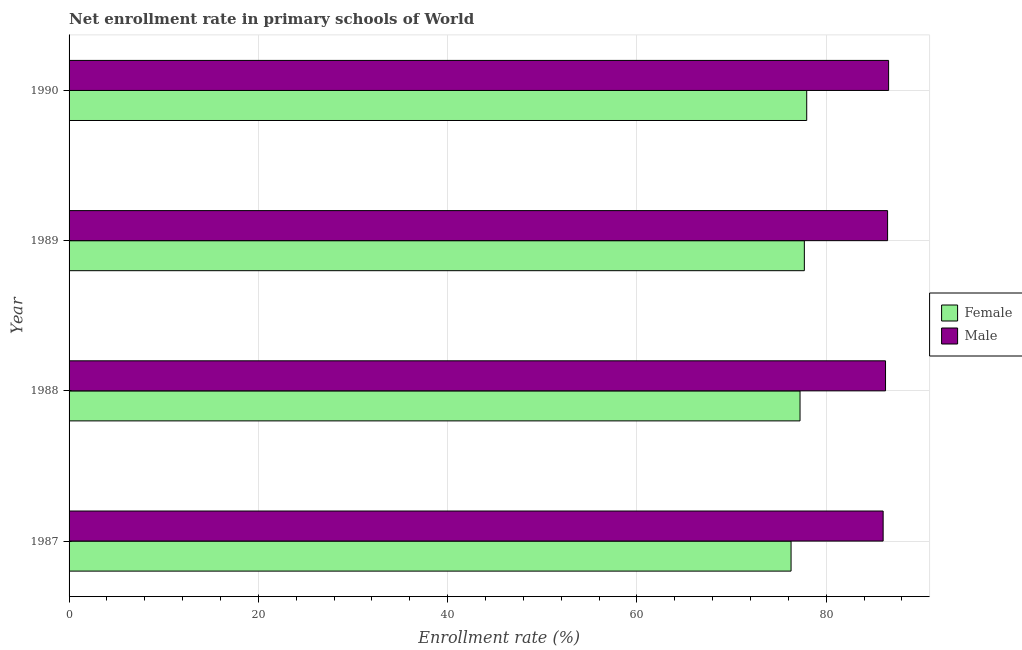How many groups of bars are there?
Make the answer very short. 4. Are the number of bars on each tick of the Y-axis equal?
Keep it short and to the point. Yes. How many bars are there on the 4th tick from the bottom?
Make the answer very short. 2. What is the label of the 2nd group of bars from the top?
Offer a very short reply. 1989. In how many cases, is the number of bars for a given year not equal to the number of legend labels?
Your answer should be compact. 0. What is the enrollment rate of male students in 1989?
Give a very brief answer. 86.49. Across all years, what is the maximum enrollment rate of male students?
Give a very brief answer. 86.6. Across all years, what is the minimum enrollment rate of female students?
Provide a succinct answer. 76.29. In which year was the enrollment rate of male students maximum?
Offer a terse response. 1990. In which year was the enrollment rate of female students minimum?
Your answer should be very brief. 1987. What is the total enrollment rate of male students in the graph?
Offer a terse response. 345.4. What is the difference between the enrollment rate of female students in 1988 and that in 1990?
Your answer should be compact. -0.71. What is the difference between the enrollment rate of male students in 1990 and the enrollment rate of female students in 1987?
Offer a terse response. 10.31. What is the average enrollment rate of male students per year?
Offer a very short reply. 86.35. In the year 1987, what is the difference between the enrollment rate of male students and enrollment rate of female students?
Ensure brevity in your answer.  9.73. In how many years, is the enrollment rate of male students greater than 64 %?
Make the answer very short. 4. What is the ratio of the enrollment rate of female students in 1988 to that in 1989?
Your answer should be very brief. 0.99. Is the difference between the enrollment rate of female students in 1989 and 1990 greater than the difference between the enrollment rate of male students in 1989 and 1990?
Your answer should be very brief. No. What is the difference between the highest and the second highest enrollment rate of female students?
Offer a very short reply. 0.25. What is the difference between the highest and the lowest enrollment rate of male students?
Ensure brevity in your answer.  0.58. What does the 2nd bar from the bottom in 1989 represents?
Keep it short and to the point. Male. Are all the bars in the graph horizontal?
Provide a succinct answer. Yes. What is the difference between two consecutive major ticks on the X-axis?
Offer a terse response. 20. Does the graph contain any zero values?
Your answer should be compact. No. Does the graph contain grids?
Provide a short and direct response. Yes. How many legend labels are there?
Offer a very short reply. 2. How are the legend labels stacked?
Provide a succinct answer. Vertical. What is the title of the graph?
Your response must be concise. Net enrollment rate in primary schools of World. What is the label or title of the X-axis?
Give a very brief answer. Enrollment rate (%). What is the label or title of the Y-axis?
Offer a terse response. Year. What is the Enrollment rate (%) of Female in 1987?
Your response must be concise. 76.29. What is the Enrollment rate (%) of Male in 1987?
Provide a short and direct response. 86.02. What is the Enrollment rate (%) in Female in 1988?
Your answer should be compact. 77.24. What is the Enrollment rate (%) of Male in 1988?
Ensure brevity in your answer.  86.28. What is the Enrollment rate (%) of Female in 1989?
Offer a terse response. 77.7. What is the Enrollment rate (%) in Male in 1989?
Provide a short and direct response. 86.49. What is the Enrollment rate (%) of Female in 1990?
Your answer should be very brief. 77.95. What is the Enrollment rate (%) in Male in 1990?
Provide a succinct answer. 86.6. Across all years, what is the maximum Enrollment rate (%) of Female?
Your answer should be compact. 77.95. Across all years, what is the maximum Enrollment rate (%) of Male?
Your answer should be compact. 86.6. Across all years, what is the minimum Enrollment rate (%) of Female?
Offer a very short reply. 76.29. Across all years, what is the minimum Enrollment rate (%) in Male?
Your answer should be very brief. 86.02. What is the total Enrollment rate (%) in Female in the graph?
Provide a short and direct response. 309.18. What is the total Enrollment rate (%) of Male in the graph?
Offer a terse response. 345.39. What is the difference between the Enrollment rate (%) of Female in 1987 and that in 1988?
Keep it short and to the point. -0.95. What is the difference between the Enrollment rate (%) of Male in 1987 and that in 1988?
Your response must be concise. -0.25. What is the difference between the Enrollment rate (%) of Female in 1987 and that in 1989?
Provide a short and direct response. -1.4. What is the difference between the Enrollment rate (%) of Male in 1987 and that in 1989?
Ensure brevity in your answer.  -0.47. What is the difference between the Enrollment rate (%) in Female in 1987 and that in 1990?
Your answer should be very brief. -1.66. What is the difference between the Enrollment rate (%) of Male in 1987 and that in 1990?
Provide a succinct answer. -0.58. What is the difference between the Enrollment rate (%) of Female in 1988 and that in 1989?
Provide a short and direct response. -0.46. What is the difference between the Enrollment rate (%) of Male in 1988 and that in 1989?
Offer a terse response. -0.22. What is the difference between the Enrollment rate (%) of Female in 1988 and that in 1990?
Provide a short and direct response. -0.71. What is the difference between the Enrollment rate (%) of Male in 1988 and that in 1990?
Your answer should be compact. -0.32. What is the difference between the Enrollment rate (%) of Female in 1989 and that in 1990?
Offer a very short reply. -0.25. What is the difference between the Enrollment rate (%) of Male in 1989 and that in 1990?
Provide a succinct answer. -0.11. What is the difference between the Enrollment rate (%) in Female in 1987 and the Enrollment rate (%) in Male in 1988?
Offer a very short reply. -9.98. What is the difference between the Enrollment rate (%) of Female in 1987 and the Enrollment rate (%) of Male in 1989?
Provide a short and direct response. -10.2. What is the difference between the Enrollment rate (%) in Female in 1987 and the Enrollment rate (%) in Male in 1990?
Your answer should be compact. -10.31. What is the difference between the Enrollment rate (%) of Female in 1988 and the Enrollment rate (%) of Male in 1989?
Offer a terse response. -9.25. What is the difference between the Enrollment rate (%) of Female in 1988 and the Enrollment rate (%) of Male in 1990?
Offer a terse response. -9.36. What is the difference between the Enrollment rate (%) of Female in 1989 and the Enrollment rate (%) of Male in 1990?
Keep it short and to the point. -8.9. What is the average Enrollment rate (%) of Female per year?
Offer a terse response. 77.29. What is the average Enrollment rate (%) of Male per year?
Your response must be concise. 86.35. In the year 1987, what is the difference between the Enrollment rate (%) of Female and Enrollment rate (%) of Male?
Make the answer very short. -9.73. In the year 1988, what is the difference between the Enrollment rate (%) of Female and Enrollment rate (%) of Male?
Provide a succinct answer. -9.04. In the year 1989, what is the difference between the Enrollment rate (%) in Female and Enrollment rate (%) in Male?
Provide a short and direct response. -8.8. In the year 1990, what is the difference between the Enrollment rate (%) of Female and Enrollment rate (%) of Male?
Your answer should be compact. -8.65. What is the ratio of the Enrollment rate (%) of Female in 1987 to that in 1988?
Provide a short and direct response. 0.99. What is the ratio of the Enrollment rate (%) in Male in 1987 to that in 1988?
Your answer should be compact. 1. What is the ratio of the Enrollment rate (%) of Female in 1987 to that in 1989?
Your response must be concise. 0.98. What is the ratio of the Enrollment rate (%) in Female in 1987 to that in 1990?
Your response must be concise. 0.98. What is the ratio of the Enrollment rate (%) of Female in 1988 to that in 1989?
Keep it short and to the point. 0.99. What is the ratio of the Enrollment rate (%) in Female in 1988 to that in 1990?
Offer a terse response. 0.99. What is the ratio of the Enrollment rate (%) of Female in 1989 to that in 1990?
Make the answer very short. 1. What is the ratio of the Enrollment rate (%) in Male in 1989 to that in 1990?
Provide a succinct answer. 1. What is the difference between the highest and the second highest Enrollment rate (%) of Female?
Provide a succinct answer. 0.25. What is the difference between the highest and the second highest Enrollment rate (%) of Male?
Offer a very short reply. 0.11. What is the difference between the highest and the lowest Enrollment rate (%) of Female?
Your response must be concise. 1.66. What is the difference between the highest and the lowest Enrollment rate (%) in Male?
Your answer should be compact. 0.58. 